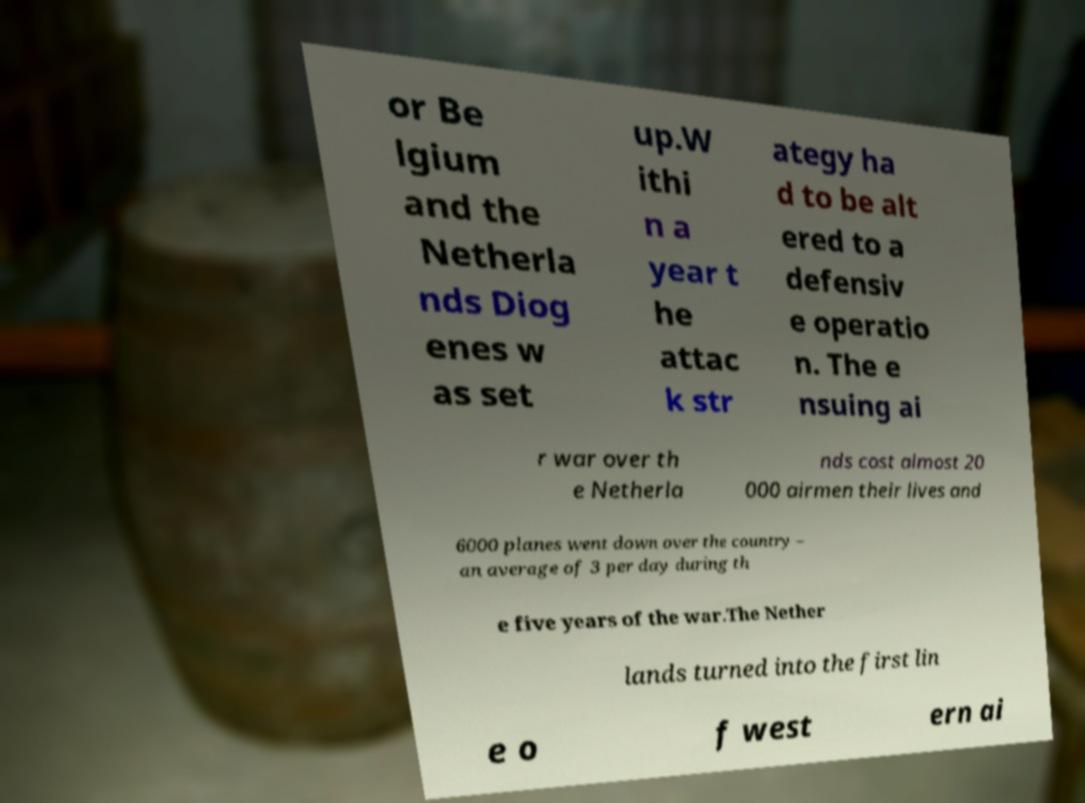Please identify and transcribe the text found in this image. or Be lgium and the Netherla nds Diog enes w as set up.W ithi n a year t he attac k str ategy ha d to be alt ered to a defensiv e operatio n. The e nsuing ai r war over th e Netherla nds cost almost 20 000 airmen their lives and 6000 planes went down over the country – an average of 3 per day during th e five years of the war.The Nether lands turned into the first lin e o f west ern ai 